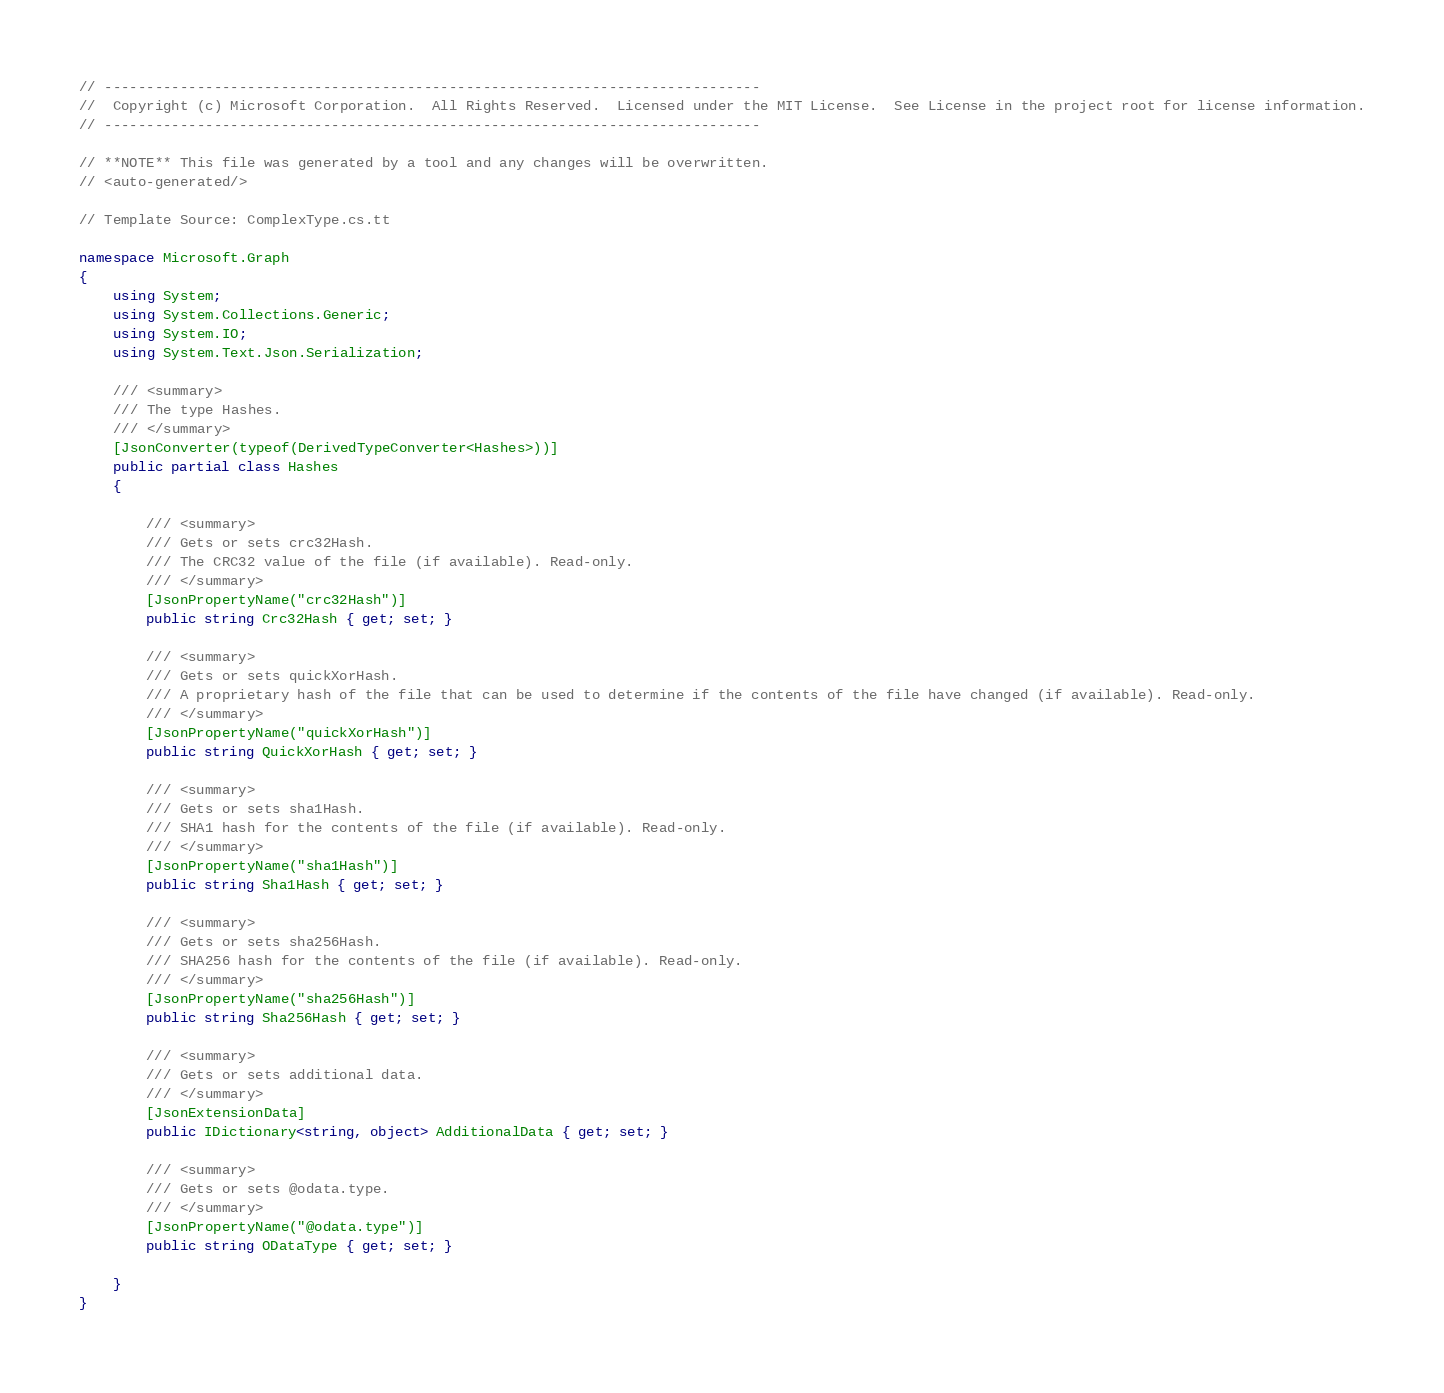Convert code to text. <code><loc_0><loc_0><loc_500><loc_500><_C#_>// ------------------------------------------------------------------------------
//  Copyright (c) Microsoft Corporation.  All Rights Reserved.  Licensed under the MIT License.  See License in the project root for license information.
// ------------------------------------------------------------------------------

// **NOTE** This file was generated by a tool and any changes will be overwritten.
// <auto-generated/>

// Template Source: ComplexType.cs.tt

namespace Microsoft.Graph
{
    using System;
    using System.Collections.Generic;
    using System.IO;
    using System.Text.Json.Serialization;

    /// <summary>
    /// The type Hashes.
    /// </summary>
    [JsonConverter(typeof(DerivedTypeConverter<Hashes>))]
    public partial class Hashes
    {

        /// <summary>
        /// Gets or sets crc32Hash.
        /// The CRC32 value of the file (if available). Read-only.
        /// </summary>
        [JsonPropertyName("crc32Hash")]
        public string Crc32Hash { get; set; }
    
        /// <summary>
        /// Gets or sets quickXorHash.
        /// A proprietary hash of the file that can be used to determine if the contents of the file have changed (if available). Read-only.
        /// </summary>
        [JsonPropertyName("quickXorHash")]
        public string QuickXorHash { get; set; }
    
        /// <summary>
        /// Gets or sets sha1Hash.
        /// SHA1 hash for the contents of the file (if available). Read-only.
        /// </summary>
        [JsonPropertyName("sha1Hash")]
        public string Sha1Hash { get; set; }
    
        /// <summary>
        /// Gets or sets sha256Hash.
        /// SHA256 hash for the contents of the file (if available). Read-only.
        /// </summary>
        [JsonPropertyName("sha256Hash")]
        public string Sha256Hash { get; set; }
    
        /// <summary>
        /// Gets or sets additional data.
        /// </summary>
        [JsonExtensionData]
        public IDictionary<string, object> AdditionalData { get; set; }

        /// <summary>
        /// Gets or sets @odata.type.
        /// </summary>
        [JsonPropertyName("@odata.type")]
        public string ODataType { get; set; }
    
    }
}
</code> 